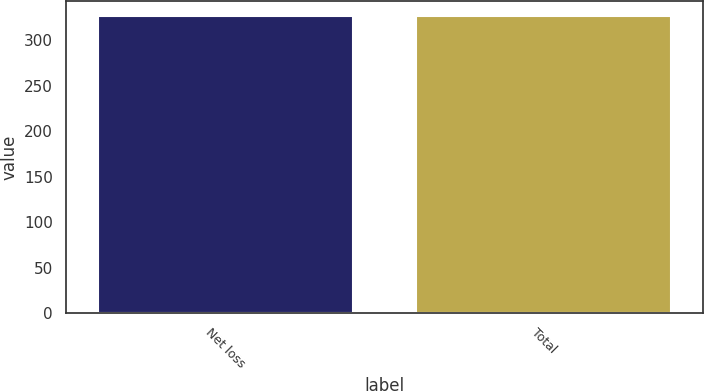Convert chart. <chart><loc_0><loc_0><loc_500><loc_500><bar_chart><fcel>Net loss<fcel>Total<nl><fcel>326<fcel>326.1<nl></chart> 